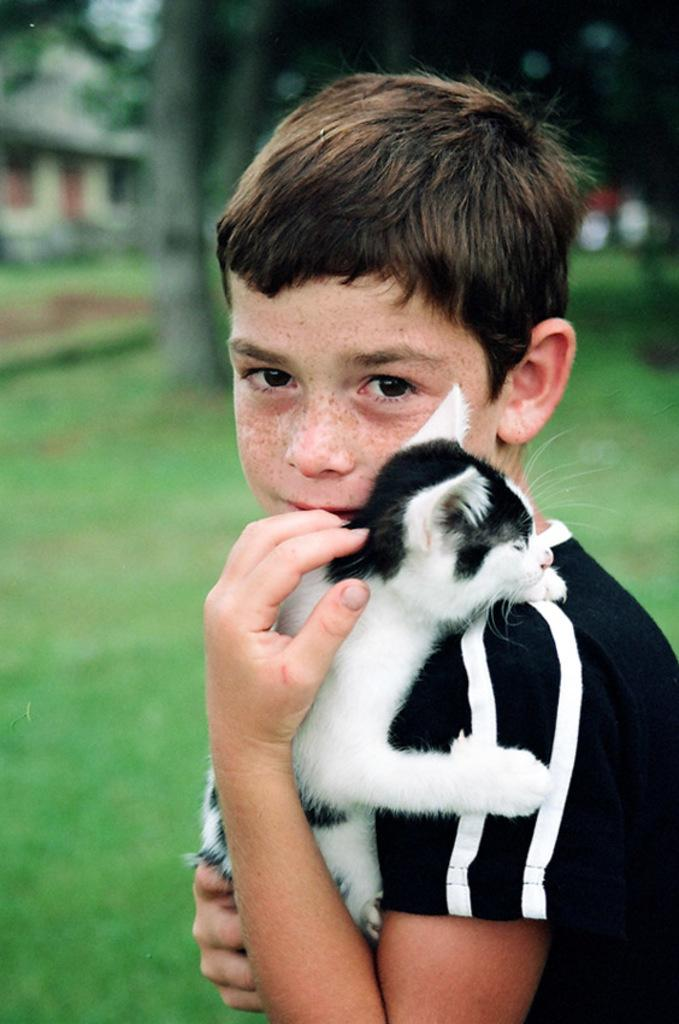Who is in the image? There is a boy in the image. What is the boy holding? The boy is holding a cat. Can you describe the cat? The cat is little. What can be seen in the background of the image? There is grass and trees in the background of the image. How are the trees in the background of the image depicted? The trees in the background of the image are slightly blurred. What type of government is depicted in the image? There is no depiction of a government in the image; it features a boy holding a cat in a natural setting. How does the pig interact with the boy in the image? There is no pig present in the image, so it cannot interact with the boy. 